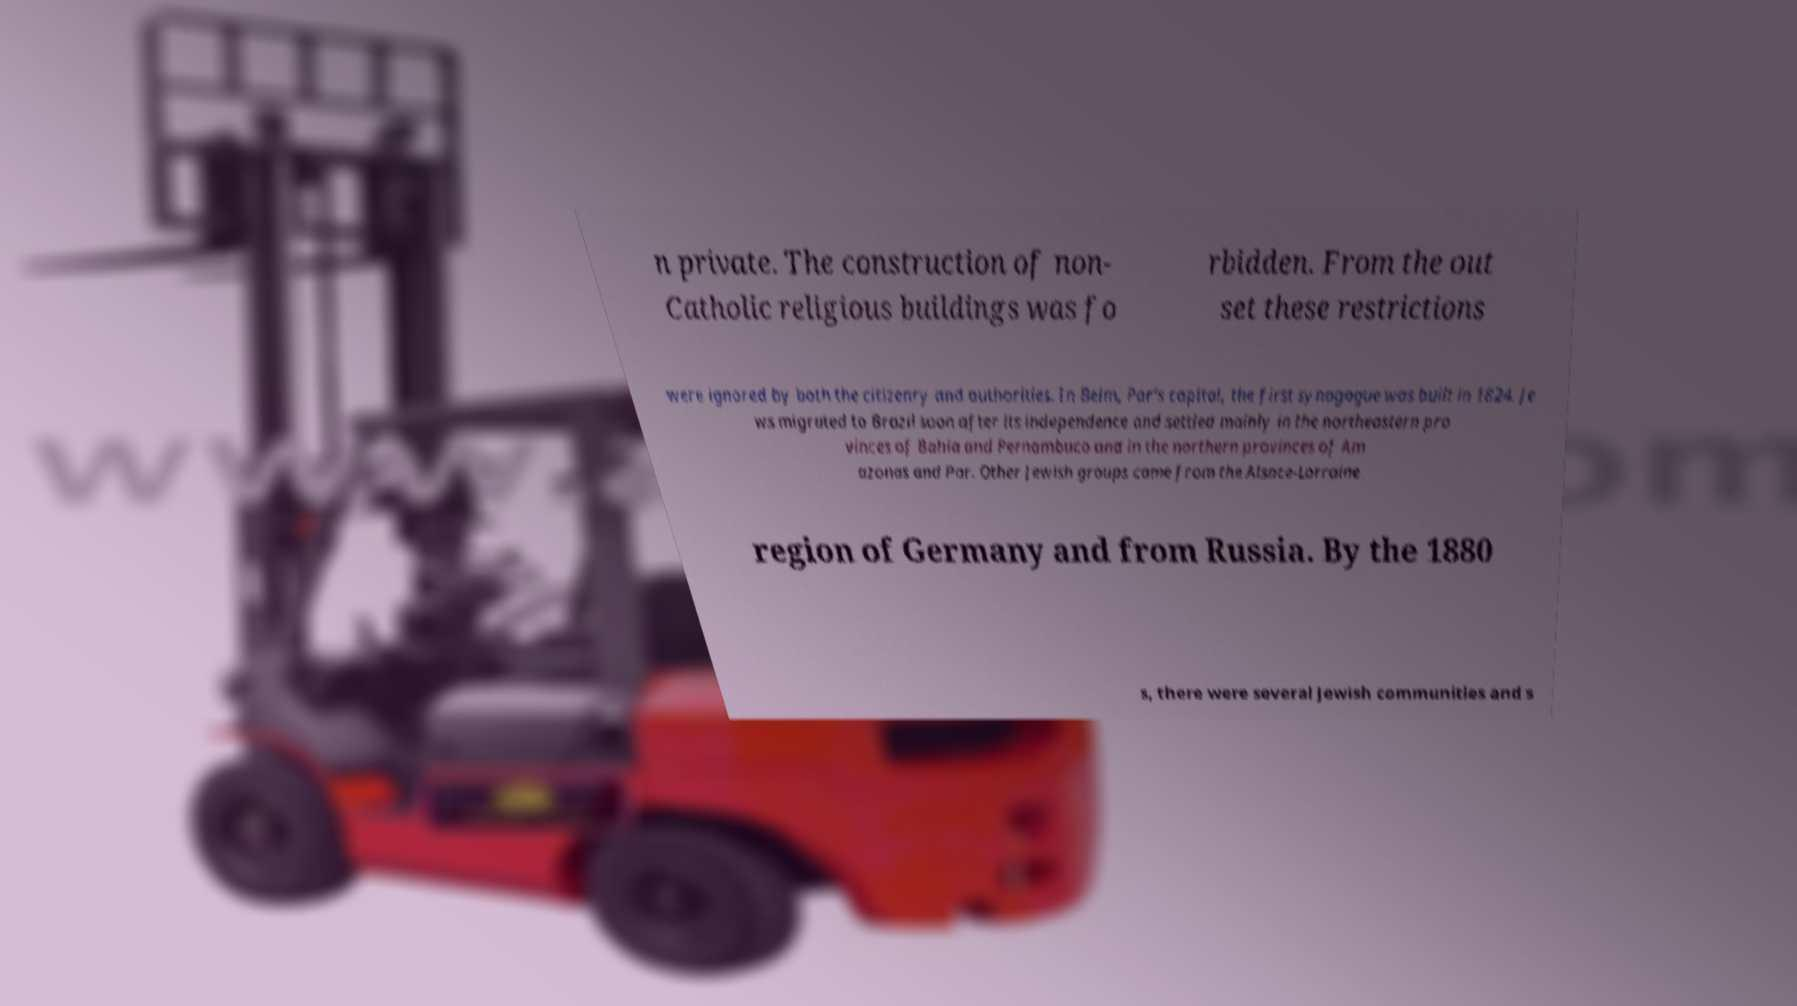What messages or text are displayed in this image? I need them in a readable, typed format. n private. The construction of non- Catholic religious buildings was fo rbidden. From the out set these restrictions were ignored by both the citizenry and authorities. In Belm, Par's capital, the first synagogue was built in 1824. Je ws migrated to Brazil soon after its independence and settled mainly in the northeastern pro vinces of Bahia and Pernambuco and in the northern provinces of Am azonas and Par. Other Jewish groups came from the Alsace-Lorraine region of Germany and from Russia. By the 1880 s, there were several Jewish communities and s 